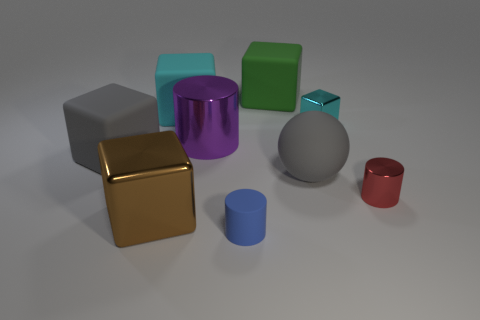Subtract 2 blocks. How many blocks are left? 3 Subtract all brown cubes. How many cubes are left? 4 Subtract all blue blocks. Subtract all purple spheres. How many blocks are left? 5 Add 1 green things. How many objects exist? 10 Subtract all cylinders. How many objects are left? 6 Add 8 tiny red cylinders. How many tiny red cylinders exist? 9 Subtract 1 blue cylinders. How many objects are left? 8 Subtract all blue matte cylinders. Subtract all blue objects. How many objects are left? 7 Add 1 large purple cylinders. How many large purple cylinders are left? 2 